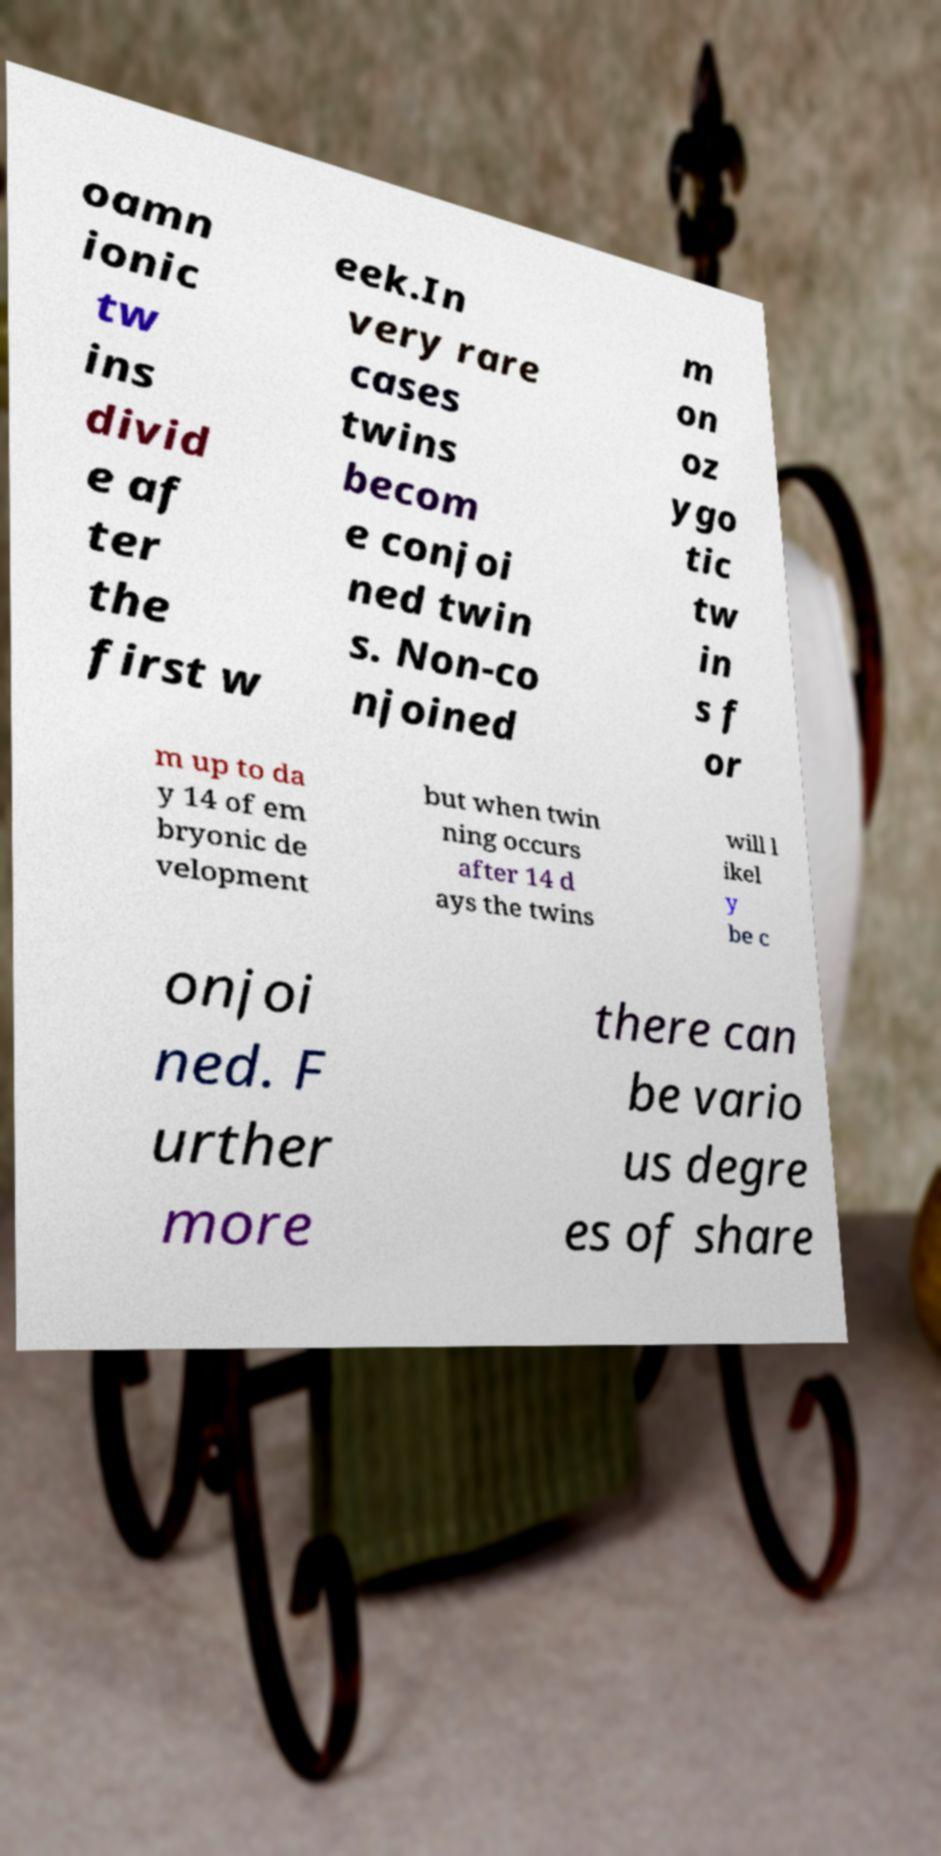Could you assist in decoding the text presented in this image and type it out clearly? oamn ionic tw ins divid e af ter the first w eek.In very rare cases twins becom e conjoi ned twin s. Non-co njoined m on oz ygo tic tw in s f or m up to da y 14 of em bryonic de velopment but when twin ning occurs after 14 d ays the twins will l ikel y be c onjoi ned. F urther more there can be vario us degre es of share 